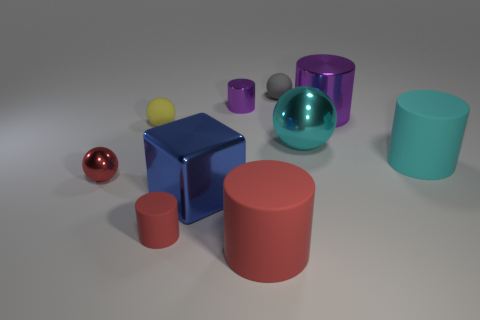Please describe the spatial arrangement of these objects. Certainly! We see a collection of geometric objects arbitrarily arranged on a flat surface. There are two larger cylinders in reddish and cyan colors clearly placed closer to the foreground. A shiny blue cube is positioned between these cylinders but more towards the background. To the left of the cube, there's a reflective red sphere, and a translucent teal sphere is seen to its right. Smaller objects including a yellow sphere, a grayish cube, and a tiny purple cylinder are scattered elsewhere in the scene, creating a varied composition. 